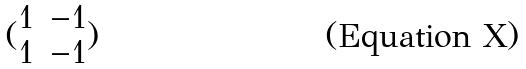Convert formula to latex. <formula><loc_0><loc_0><loc_500><loc_500>( \begin{matrix} 1 & - 1 \\ 1 & - 1 \end{matrix} )</formula> 